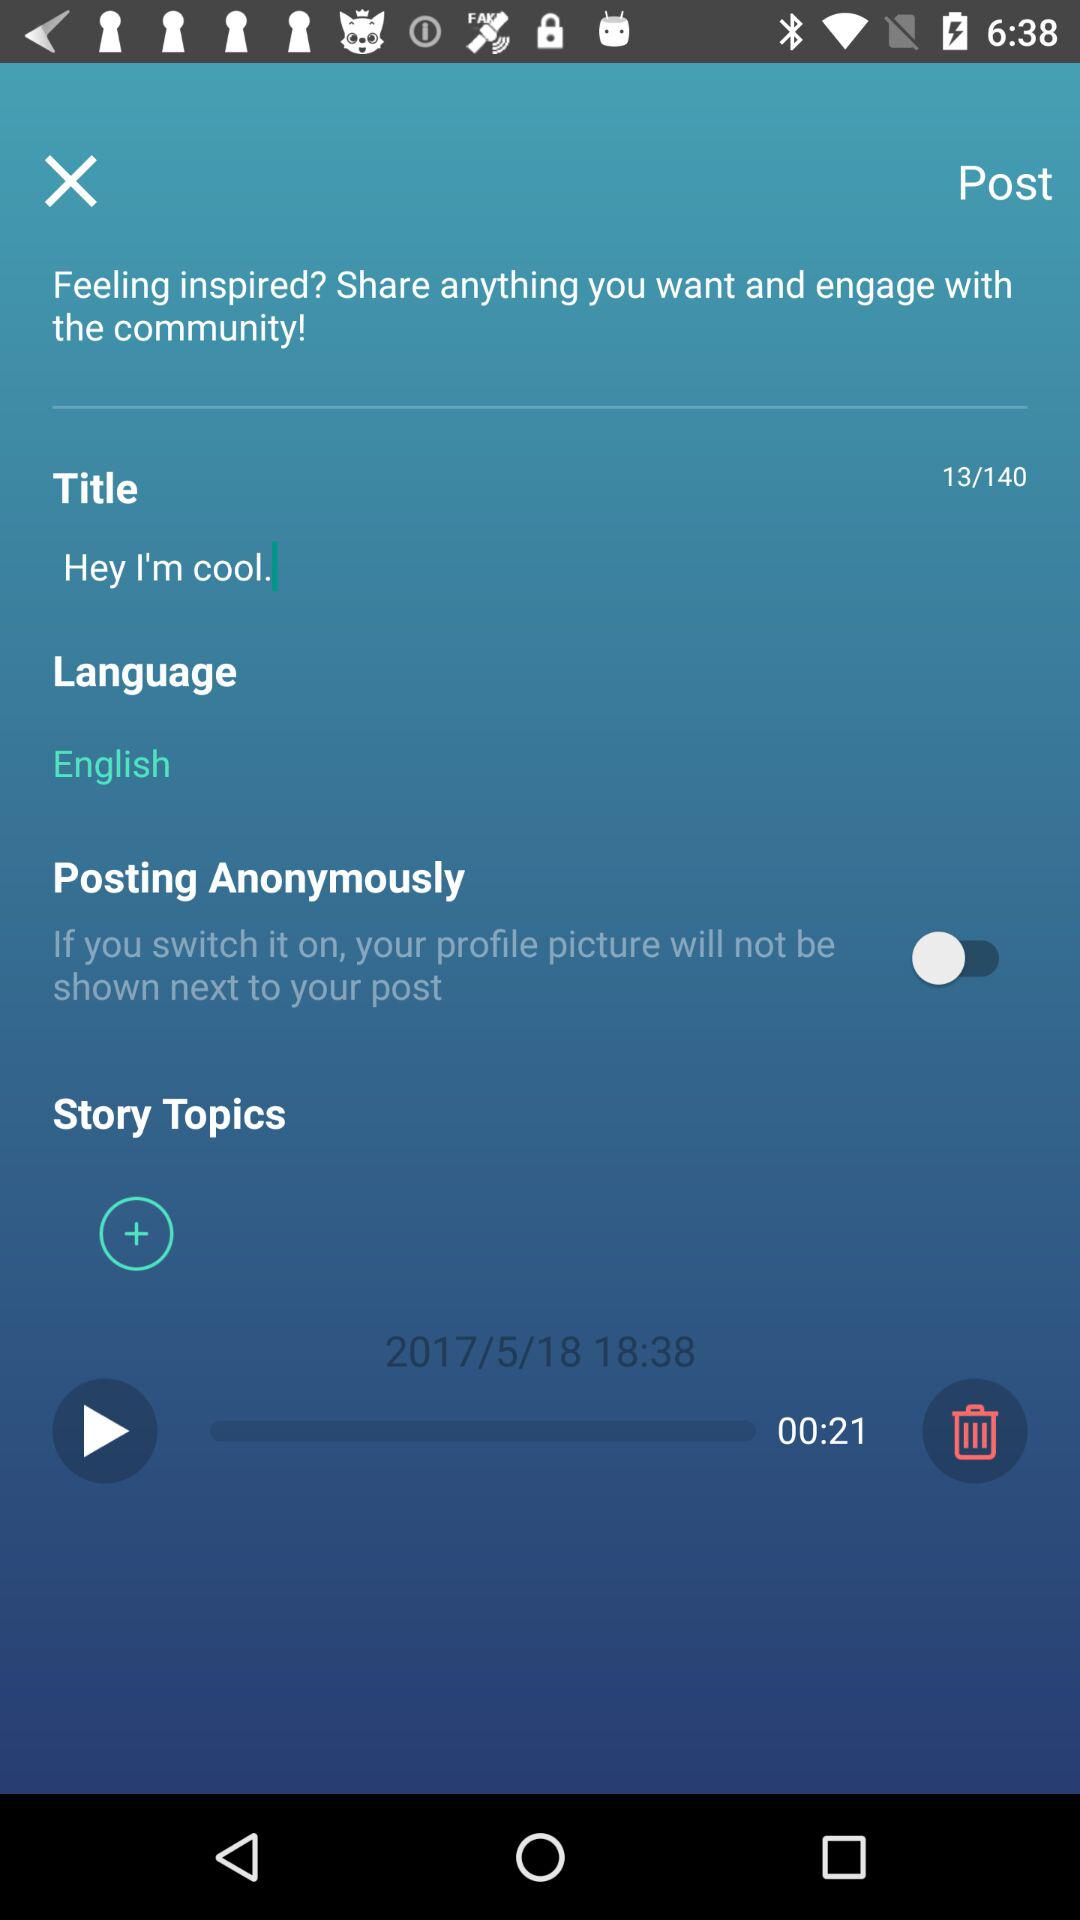What is the status of "Posting Anonymously"? The status is "off". 